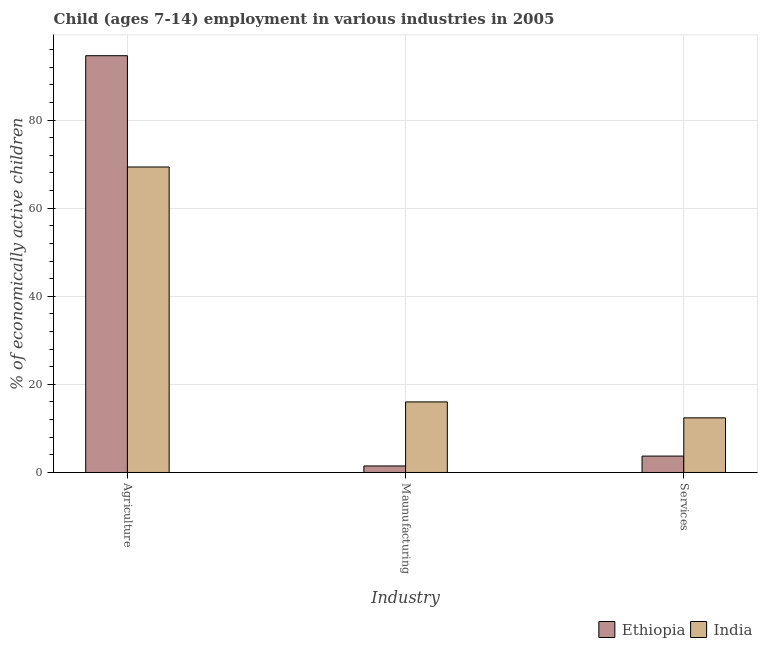How many groups of bars are there?
Keep it short and to the point. 3. Are the number of bars on each tick of the X-axis equal?
Provide a succinct answer. Yes. How many bars are there on the 3rd tick from the right?
Your answer should be very brief. 2. What is the label of the 2nd group of bars from the left?
Offer a terse response. Maunufacturing. What is the percentage of economically active children in manufacturing in Ethiopia?
Your answer should be compact. 1.48. Across all countries, what is the maximum percentage of economically active children in manufacturing?
Offer a very short reply. 16.02. Across all countries, what is the minimum percentage of economically active children in agriculture?
Offer a very short reply. 69.35. In which country was the percentage of economically active children in manufacturing minimum?
Offer a terse response. Ethiopia. What is the difference between the percentage of economically active children in manufacturing in Ethiopia and that in India?
Provide a succinct answer. -14.54. What is the difference between the percentage of economically active children in manufacturing in India and the percentage of economically active children in agriculture in Ethiopia?
Provide a short and direct response. -78.59. What is the average percentage of economically active children in services per country?
Keep it short and to the point. 8.06. What is the difference between the percentage of economically active children in manufacturing and percentage of economically active children in services in India?
Give a very brief answer. 3.62. In how many countries, is the percentage of economically active children in services greater than 4 %?
Offer a very short reply. 1. What is the ratio of the percentage of economically active children in services in India to that in Ethiopia?
Make the answer very short. 3.33. Is the percentage of economically active children in manufacturing in Ethiopia less than that in India?
Provide a succinct answer. Yes. Is the difference between the percentage of economically active children in services in India and Ethiopia greater than the difference between the percentage of economically active children in agriculture in India and Ethiopia?
Give a very brief answer. Yes. What is the difference between the highest and the second highest percentage of economically active children in agriculture?
Give a very brief answer. 25.26. What is the difference between the highest and the lowest percentage of economically active children in services?
Ensure brevity in your answer.  8.68. In how many countries, is the percentage of economically active children in agriculture greater than the average percentage of economically active children in agriculture taken over all countries?
Your answer should be compact. 1. What does the 2nd bar from the left in Services represents?
Ensure brevity in your answer.  India. What does the 2nd bar from the right in Maunufacturing represents?
Offer a very short reply. Ethiopia. How many bars are there?
Provide a succinct answer. 6. Are all the bars in the graph horizontal?
Provide a succinct answer. No. Does the graph contain any zero values?
Make the answer very short. No. Does the graph contain grids?
Keep it short and to the point. Yes. Where does the legend appear in the graph?
Keep it short and to the point. Bottom right. What is the title of the graph?
Ensure brevity in your answer.  Child (ages 7-14) employment in various industries in 2005. What is the label or title of the X-axis?
Ensure brevity in your answer.  Industry. What is the label or title of the Y-axis?
Your answer should be very brief. % of economically active children. What is the % of economically active children of Ethiopia in Agriculture?
Your response must be concise. 94.61. What is the % of economically active children in India in Agriculture?
Keep it short and to the point. 69.35. What is the % of economically active children of Ethiopia in Maunufacturing?
Your response must be concise. 1.48. What is the % of economically active children of India in Maunufacturing?
Provide a short and direct response. 16.02. What is the % of economically active children of Ethiopia in Services?
Make the answer very short. 3.72. Across all Industry, what is the maximum % of economically active children in Ethiopia?
Your response must be concise. 94.61. Across all Industry, what is the maximum % of economically active children in India?
Ensure brevity in your answer.  69.35. Across all Industry, what is the minimum % of economically active children in Ethiopia?
Your answer should be compact. 1.48. What is the total % of economically active children of Ethiopia in the graph?
Offer a very short reply. 99.81. What is the total % of economically active children of India in the graph?
Make the answer very short. 97.77. What is the difference between the % of economically active children of Ethiopia in Agriculture and that in Maunufacturing?
Ensure brevity in your answer.  93.13. What is the difference between the % of economically active children in India in Agriculture and that in Maunufacturing?
Provide a short and direct response. 53.33. What is the difference between the % of economically active children of Ethiopia in Agriculture and that in Services?
Offer a very short reply. 90.89. What is the difference between the % of economically active children of India in Agriculture and that in Services?
Provide a short and direct response. 56.95. What is the difference between the % of economically active children in Ethiopia in Maunufacturing and that in Services?
Give a very brief answer. -2.24. What is the difference between the % of economically active children of India in Maunufacturing and that in Services?
Your answer should be very brief. 3.62. What is the difference between the % of economically active children in Ethiopia in Agriculture and the % of economically active children in India in Maunufacturing?
Your answer should be very brief. 78.59. What is the difference between the % of economically active children of Ethiopia in Agriculture and the % of economically active children of India in Services?
Your answer should be very brief. 82.21. What is the difference between the % of economically active children of Ethiopia in Maunufacturing and the % of economically active children of India in Services?
Make the answer very short. -10.92. What is the average % of economically active children in Ethiopia per Industry?
Make the answer very short. 33.27. What is the average % of economically active children of India per Industry?
Offer a terse response. 32.59. What is the difference between the % of economically active children in Ethiopia and % of economically active children in India in Agriculture?
Your response must be concise. 25.26. What is the difference between the % of economically active children in Ethiopia and % of economically active children in India in Maunufacturing?
Offer a very short reply. -14.54. What is the difference between the % of economically active children in Ethiopia and % of economically active children in India in Services?
Provide a succinct answer. -8.68. What is the ratio of the % of economically active children in Ethiopia in Agriculture to that in Maunufacturing?
Provide a succinct answer. 63.93. What is the ratio of the % of economically active children of India in Agriculture to that in Maunufacturing?
Provide a succinct answer. 4.33. What is the ratio of the % of economically active children in Ethiopia in Agriculture to that in Services?
Your answer should be very brief. 25.43. What is the ratio of the % of economically active children in India in Agriculture to that in Services?
Provide a succinct answer. 5.59. What is the ratio of the % of economically active children of Ethiopia in Maunufacturing to that in Services?
Give a very brief answer. 0.4. What is the ratio of the % of economically active children of India in Maunufacturing to that in Services?
Your answer should be compact. 1.29. What is the difference between the highest and the second highest % of economically active children of Ethiopia?
Provide a short and direct response. 90.89. What is the difference between the highest and the second highest % of economically active children of India?
Make the answer very short. 53.33. What is the difference between the highest and the lowest % of economically active children of Ethiopia?
Provide a succinct answer. 93.13. What is the difference between the highest and the lowest % of economically active children of India?
Give a very brief answer. 56.95. 